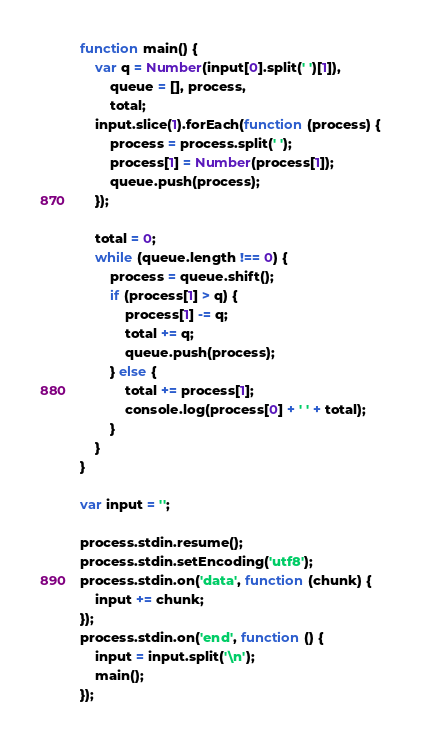Convert code to text. <code><loc_0><loc_0><loc_500><loc_500><_JavaScript_>function main() {
    var q = Number(input[0].split(' ')[1]),
        queue = [], process,
        total;
    input.slice(1).forEach(function (process) {
        process = process.split(' ');
        process[1] = Number(process[1]);
        queue.push(process);
    });

    total = 0;
    while (queue.length !== 0) {
        process = queue.shift();
        if (process[1] > q) {
            process[1] -= q;
            total += q;
            queue.push(process);
        } else {
            total += process[1];
            console.log(process[0] + ' ' + total);
        }
    }
}

var input = '';

process.stdin.resume();
process.stdin.setEncoding('utf8');
process.stdin.on('data', function (chunk) {
    input += chunk;
});
process.stdin.on('end', function () {
    input = input.split('\n');
    main();
});</code> 